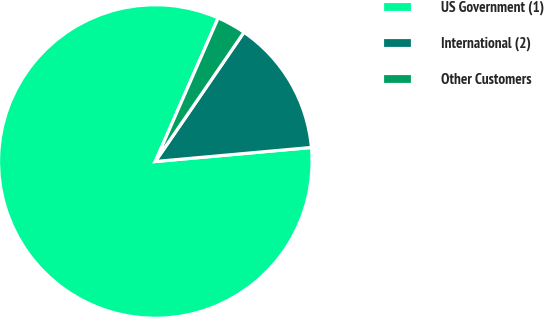Convert chart. <chart><loc_0><loc_0><loc_500><loc_500><pie_chart><fcel>US Government (1)<fcel>International (2)<fcel>Other Customers<nl><fcel>83.0%<fcel>14.0%<fcel>3.0%<nl></chart> 